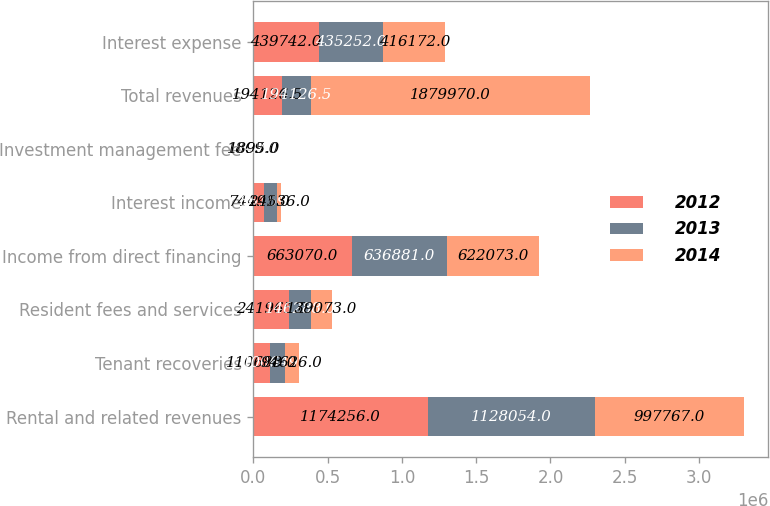<chart> <loc_0><loc_0><loc_500><loc_500><stacked_bar_chart><ecel><fcel>Rental and related revenues<fcel>Tenant recoveries<fcel>Resident fees and services<fcel>Income from direct financing<fcel>Interest income<fcel>Investment management fee<fcel>Total revenues<fcel>Interest expense<nl><fcel>2012<fcel>1.17426e+06<fcel>110688<fcel>241965<fcel>663070<fcel>74491<fcel>1809<fcel>194126<fcel>439742<nl><fcel>2013<fcel>1.12805e+06<fcel>100649<fcel>146288<fcel>636881<fcel>86159<fcel>1847<fcel>194126<fcel>435252<nl><fcel>2014<fcel>997767<fcel>94626<fcel>139073<fcel>622073<fcel>24536<fcel>1895<fcel>1.87997e+06<fcel>416172<nl></chart> 